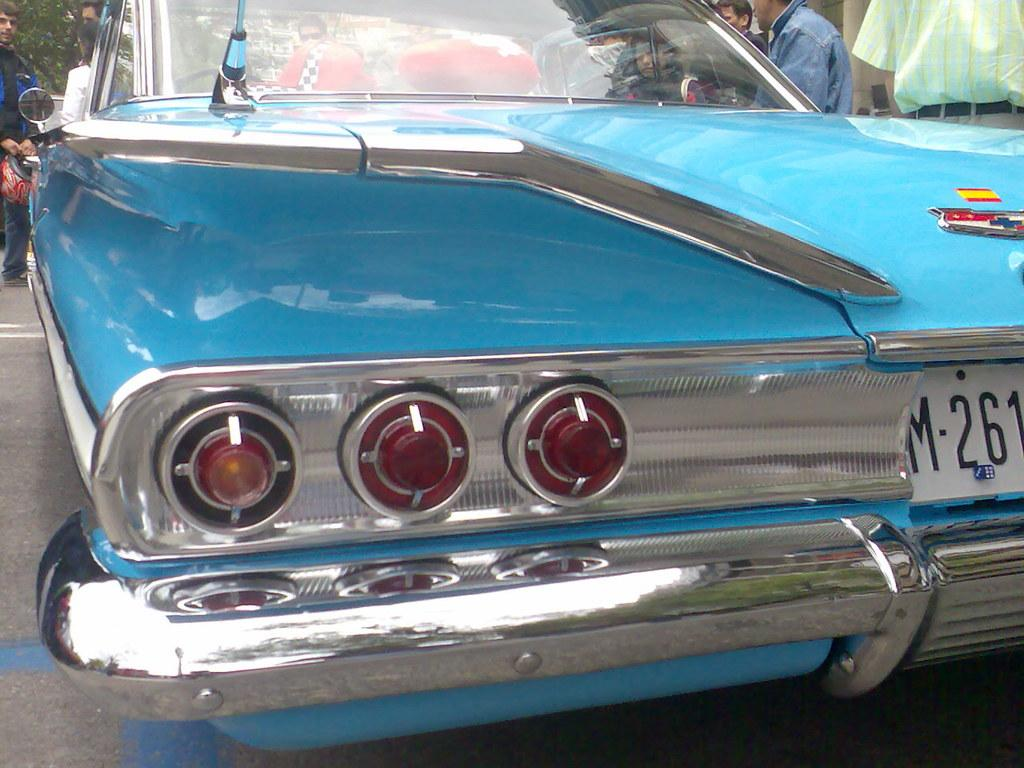What color is the car in the image? The car in the image is blue. What is the car doing in the image? The car is parked. Are there any people in the image? Yes, there are people in the image. Can you describe the man in the image? The man is standing and holding a helmet in his hand. What can be seen in the background of the image? There is a tree visible in the image. What type of prison is visible in the image? There is no prison present in the image. What activity are the people in the image participating in? The provided facts do not mention any specific activity that the people in the image are participating in. 